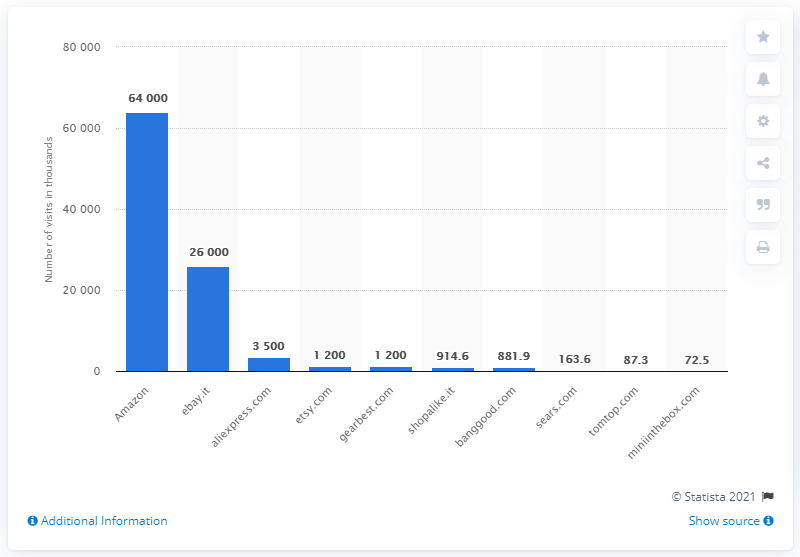Draw attention to some important aspects in this diagram. In July 2019, Amazon was the most visited website in Italy. In July 2019, aliexpress.com was the third most visited website in Italy. 